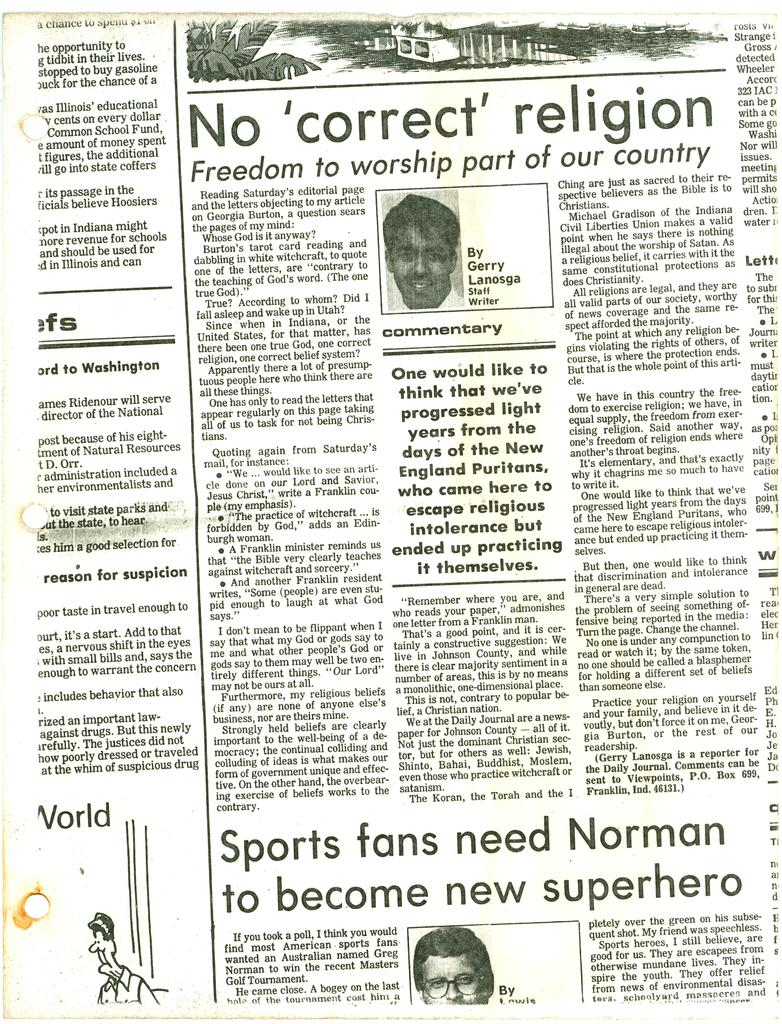What is written on the paper in the image? The facts do not specify what is written on the paper, so we cannot answer that question definitively. What type of image is present in the image? There is a cartoon picture in the image. How many pictures of persons are in the image? There are two pictures of persons in the image. What does the paper smell like in the image? The facts do not mention anything about the smell of the paper, so we cannot answer that question definitively. 